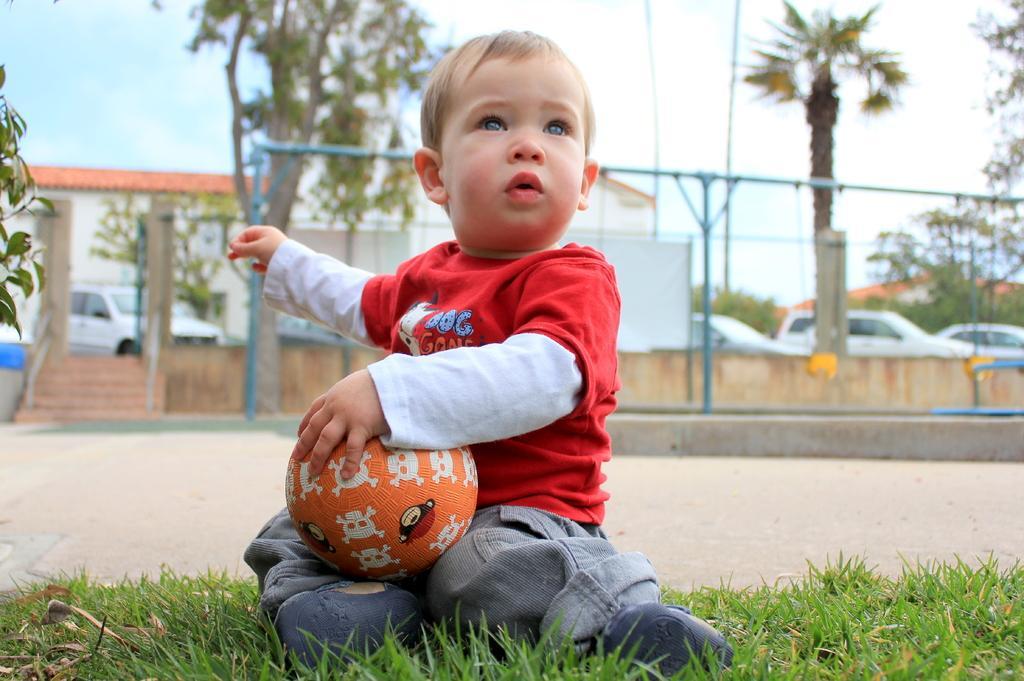Can you describe this image briefly? In this picture there is a kid, sitting on the grass in the lawn, holding a ball in his hands. In the background there is a fence, cat, trees and a sky with some clouds here. 